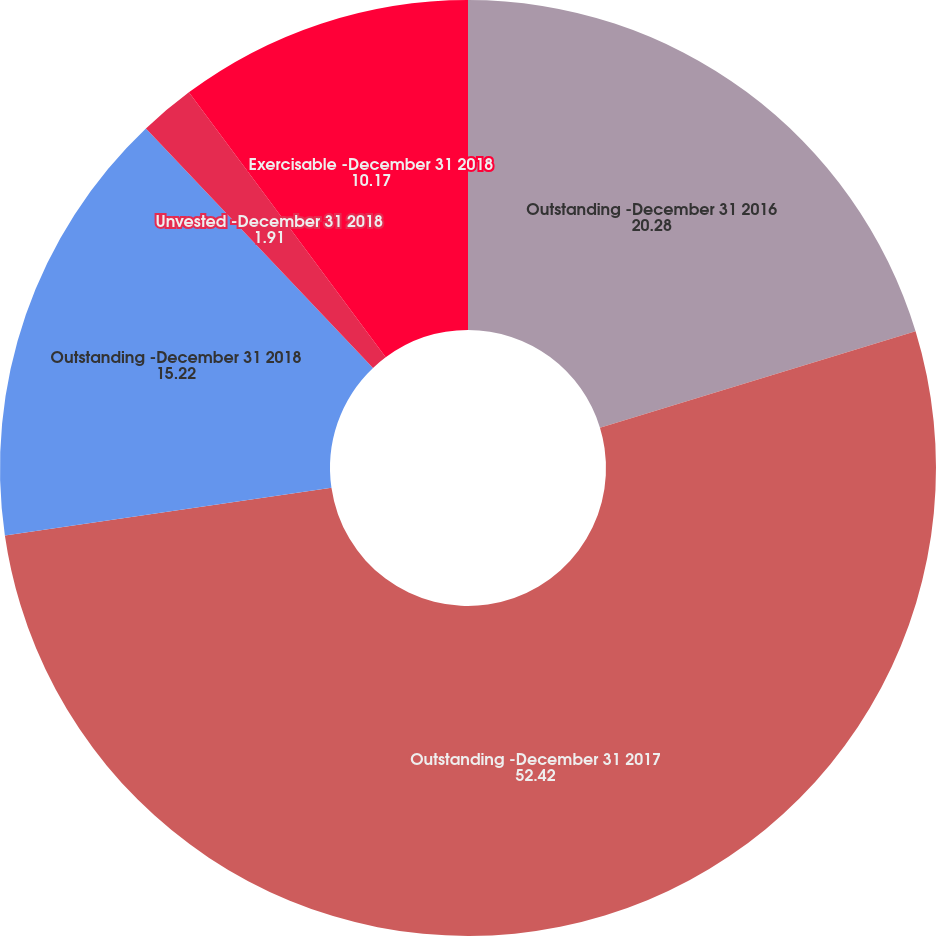<chart> <loc_0><loc_0><loc_500><loc_500><pie_chart><fcel>Outstanding -December 31 2016<fcel>Outstanding -December 31 2017<fcel>Outstanding -December 31 2018<fcel>Unvested -December 31 2018<fcel>Exercisable -December 31 2018<nl><fcel>20.28%<fcel>52.42%<fcel>15.22%<fcel>1.91%<fcel>10.17%<nl></chart> 